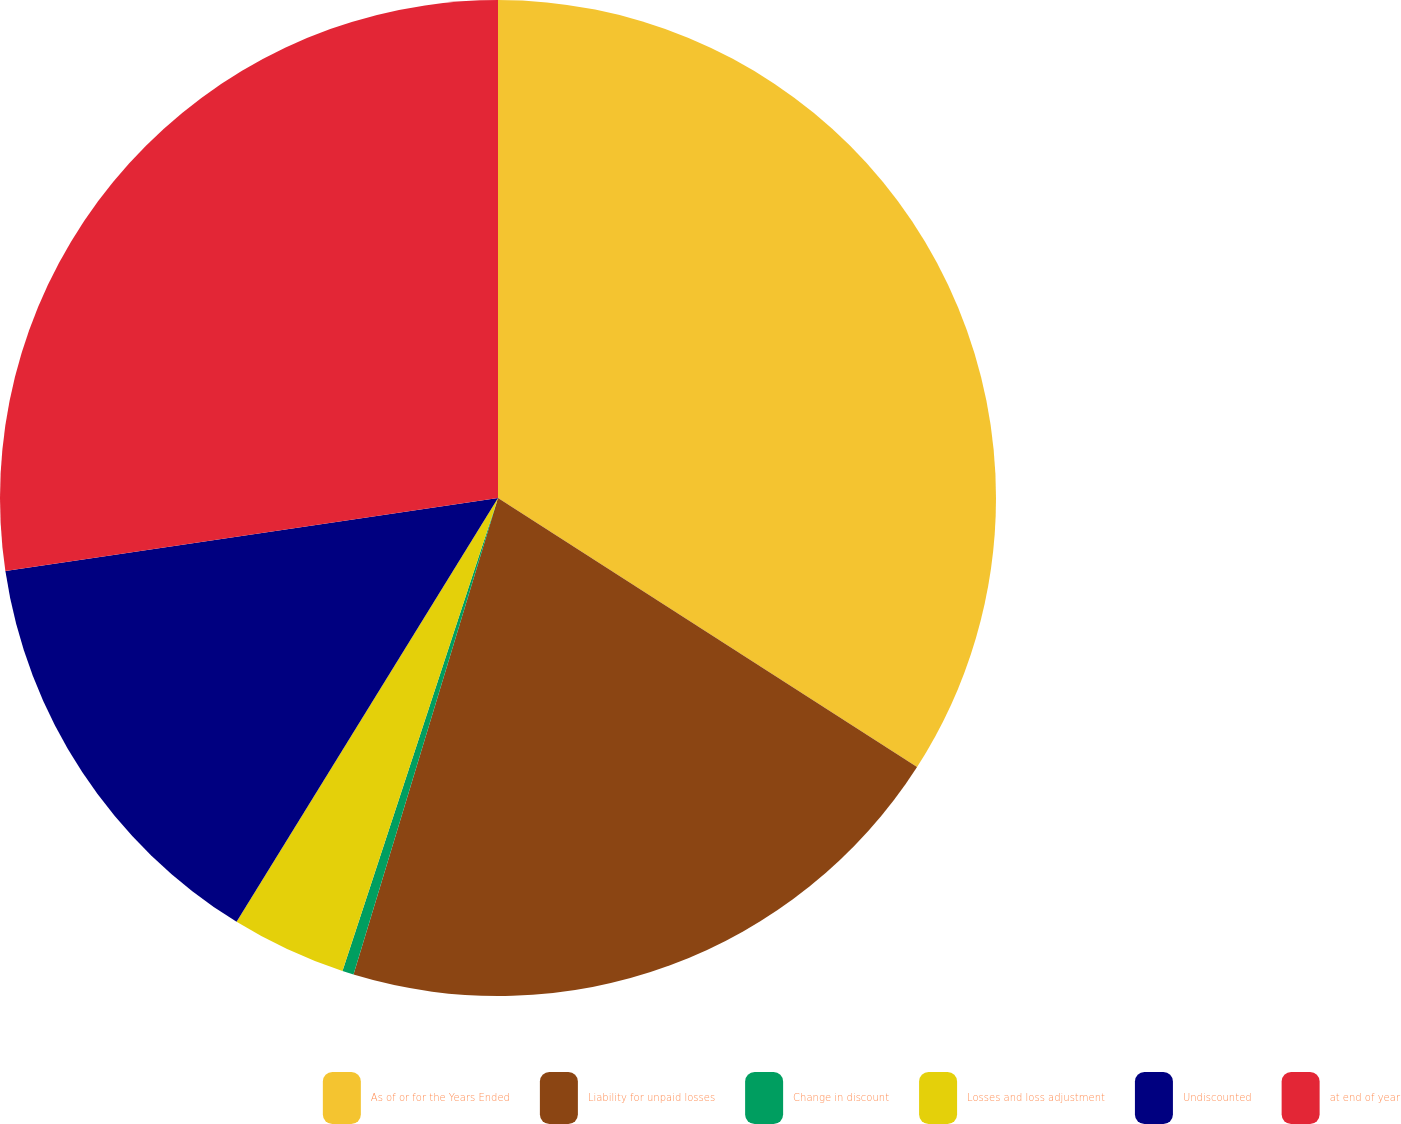Convert chart. <chart><loc_0><loc_0><loc_500><loc_500><pie_chart><fcel>As of or for the Years Ended<fcel>Liability for unpaid losses<fcel>Change in discount<fcel>Losses and loss adjustment<fcel>Undiscounted<fcel>at end of year<nl><fcel>34.08%<fcel>20.6%<fcel>0.37%<fcel>3.74%<fcel>13.86%<fcel>27.34%<nl></chart> 